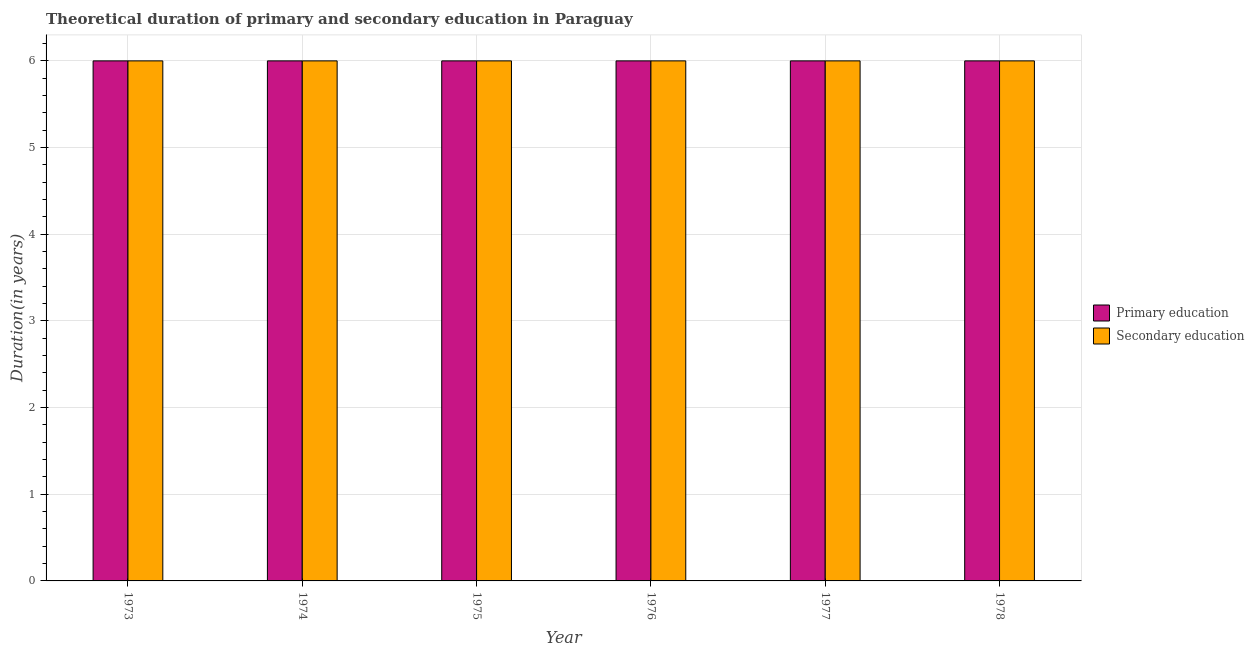How many different coloured bars are there?
Your answer should be compact. 2. How many groups of bars are there?
Offer a terse response. 6. How many bars are there on the 2nd tick from the right?
Provide a short and direct response. 2. What is the duration of secondary education in 1974?
Offer a very short reply. 6. Across all years, what is the maximum duration of secondary education?
Offer a terse response. 6. In which year was the duration of primary education minimum?
Offer a terse response. 1973. What is the total duration of secondary education in the graph?
Offer a terse response. 36. In how many years, is the duration of secondary education greater than 2.2 years?
Ensure brevity in your answer.  6. Is the difference between the duration of primary education in 1974 and 1975 greater than the difference between the duration of secondary education in 1974 and 1975?
Your response must be concise. No. What is the difference between the highest and the second highest duration of primary education?
Provide a short and direct response. 0. In how many years, is the duration of secondary education greater than the average duration of secondary education taken over all years?
Provide a short and direct response. 0. Is the sum of the duration of primary education in 1973 and 1976 greater than the maximum duration of secondary education across all years?
Your answer should be compact. Yes. What does the 2nd bar from the left in 1973 represents?
Your answer should be compact. Secondary education. How many bars are there?
Provide a short and direct response. 12. Are all the bars in the graph horizontal?
Make the answer very short. No. How many years are there in the graph?
Your answer should be compact. 6. What is the difference between two consecutive major ticks on the Y-axis?
Make the answer very short. 1. Does the graph contain any zero values?
Keep it short and to the point. No. Does the graph contain grids?
Provide a short and direct response. Yes. How many legend labels are there?
Provide a short and direct response. 2. What is the title of the graph?
Ensure brevity in your answer.  Theoretical duration of primary and secondary education in Paraguay. Does "Crop" appear as one of the legend labels in the graph?
Your answer should be compact. No. What is the label or title of the X-axis?
Your answer should be compact. Year. What is the label or title of the Y-axis?
Provide a short and direct response. Duration(in years). What is the Duration(in years) of Primary education in 1973?
Offer a very short reply. 6. What is the Duration(in years) in Primary education in 1974?
Give a very brief answer. 6. What is the Duration(in years) in Primary education in 1975?
Give a very brief answer. 6. What is the Duration(in years) of Secondary education in 1976?
Your answer should be very brief. 6. What is the Duration(in years) in Primary education in 1977?
Offer a very short reply. 6. What is the Duration(in years) of Secondary education in 1977?
Your answer should be very brief. 6. What is the Duration(in years) in Secondary education in 1978?
Make the answer very short. 6. Across all years, what is the maximum Duration(in years) in Primary education?
Your response must be concise. 6. Across all years, what is the maximum Duration(in years) of Secondary education?
Provide a succinct answer. 6. What is the total Duration(in years) in Primary education in the graph?
Give a very brief answer. 36. What is the difference between the Duration(in years) in Primary education in 1973 and that in 1974?
Keep it short and to the point. 0. What is the difference between the Duration(in years) of Secondary education in 1973 and that in 1974?
Provide a succinct answer. 0. What is the difference between the Duration(in years) of Primary education in 1973 and that in 1976?
Your answer should be very brief. 0. What is the difference between the Duration(in years) of Secondary education in 1973 and that in 1976?
Provide a short and direct response. 0. What is the difference between the Duration(in years) of Primary education in 1974 and that in 1975?
Offer a very short reply. 0. What is the difference between the Duration(in years) in Secondary education in 1974 and that in 1975?
Provide a short and direct response. 0. What is the difference between the Duration(in years) of Primary education in 1974 and that in 1976?
Offer a terse response. 0. What is the difference between the Duration(in years) in Primary education in 1974 and that in 1978?
Provide a succinct answer. 0. What is the difference between the Duration(in years) in Secondary education in 1974 and that in 1978?
Offer a terse response. 0. What is the difference between the Duration(in years) of Primary education in 1975 and that in 1976?
Give a very brief answer. 0. What is the difference between the Duration(in years) in Secondary education in 1975 and that in 1976?
Offer a very short reply. 0. What is the difference between the Duration(in years) of Primary education in 1975 and that in 1978?
Give a very brief answer. 0. What is the difference between the Duration(in years) of Primary education in 1977 and that in 1978?
Your answer should be compact. 0. What is the difference between the Duration(in years) of Primary education in 1973 and the Duration(in years) of Secondary education in 1974?
Provide a short and direct response. 0. What is the difference between the Duration(in years) of Primary education in 1973 and the Duration(in years) of Secondary education in 1975?
Your answer should be very brief. 0. What is the difference between the Duration(in years) of Primary education in 1973 and the Duration(in years) of Secondary education in 1976?
Make the answer very short. 0. What is the difference between the Duration(in years) in Primary education in 1973 and the Duration(in years) in Secondary education in 1978?
Offer a very short reply. 0. What is the difference between the Duration(in years) of Primary education in 1974 and the Duration(in years) of Secondary education in 1975?
Provide a succinct answer. 0. What is the difference between the Duration(in years) in Primary education in 1974 and the Duration(in years) in Secondary education in 1976?
Provide a succinct answer. 0. What is the difference between the Duration(in years) of Primary education in 1974 and the Duration(in years) of Secondary education in 1977?
Ensure brevity in your answer.  0. What is the difference between the Duration(in years) of Primary education in 1974 and the Duration(in years) of Secondary education in 1978?
Offer a very short reply. 0. What is the difference between the Duration(in years) in Primary education in 1975 and the Duration(in years) in Secondary education in 1977?
Make the answer very short. 0. In the year 1973, what is the difference between the Duration(in years) in Primary education and Duration(in years) in Secondary education?
Offer a terse response. 0. In the year 1974, what is the difference between the Duration(in years) in Primary education and Duration(in years) in Secondary education?
Make the answer very short. 0. In the year 1975, what is the difference between the Duration(in years) in Primary education and Duration(in years) in Secondary education?
Ensure brevity in your answer.  0. In the year 1976, what is the difference between the Duration(in years) in Primary education and Duration(in years) in Secondary education?
Provide a short and direct response. 0. What is the ratio of the Duration(in years) of Primary education in 1973 to that in 1975?
Your answer should be very brief. 1. What is the ratio of the Duration(in years) of Primary education in 1973 to that in 1976?
Ensure brevity in your answer.  1. What is the ratio of the Duration(in years) of Primary education in 1973 to that in 1977?
Your answer should be very brief. 1. What is the ratio of the Duration(in years) in Secondary education in 1973 to that in 1977?
Your response must be concise. 1. What is the ratio of the Duration(in years) in Primary education in 1974 to that in 1975?
Make the answer very short. 1. What is the ratio of the Duration(in years) in Primary education in 1974 to that in 1976?
Provide a succinct answer. 1. What is the ratio of the Duration(in years) of Secondary education in 1974 to that in 1976?
Your response must be concise. 1. What is the ratio of the Duration(in years) of Primary education in 1974 to that in 1977?
Offer a terse response. 1. What is the ratio of the Duration(in years) of Secondary education in 1974 to that in 1977?
Offer a terse response. 1. What is the ratio of the Duration(in years) in Primary education in 1974 to that in 1978?
Your response must be concise. 1. What is the ratio of the Duration(in years) in Secondary education in 1975 to that in 1976?
Provide a succinct answer. 1. What is the ratio of the Duration(in years) in Secondary education in 1975 to that in 1977?
Provide a short and direct response. 1. What is the ratio of the Duration(in years) of Primary education in 1975 to that in 1978?
Keep it short and to the point. 1. What is the ratio of the Duration(in years) in Secondary education in 1975 to that in 1978?
Give a very brief answer. 1. What is the ratio of the Duration(in years) of Secondary education in 1976 to that in 1977?
Make the answer very short. 1. What is the ratio of the Duration(in years) in Secondary education in 1976 to that in 1978?
Offer a very short reply. 1. What is the ratio of the Duration(in years) of Primary education in 1977 to that in 1978?
Provide a succinct answer. 1. What is the difference between the highest and the lowest Duration(in years) of Secondary education?
Offer a very short reply. 0. 